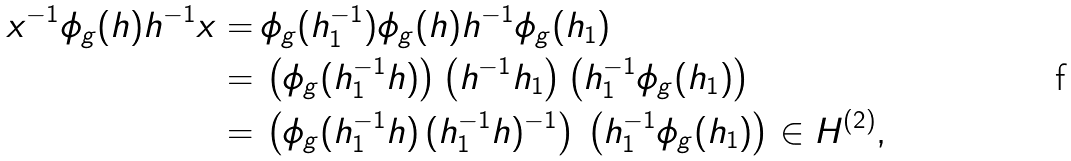<formula> <loc_0><loc_0><loc_500><loc_500>x ^ { - 1 } \phi _ { g } ( h ) h ^ { - 1 } x = & \, \phi _ { g } ( h _ { 1 } ^ { - 1 } ) \phi _ { g } ( h ) h ^ { - 1 } \phi _ { g } ( h _ { 1 } ) \\ = & \, \left ( \phi _ { g } ( h _ { 1 } ^ { - 1 } h ) \right ) \left ( h ^ { - 1 } h _ { 1 } \right ) \left ( h ^ { - 1 } _ { 1 } \phi _ { g } ( h _ { 1 } ) \right ) \\ = & \, \left ( \phi _ { g } ( h _ { 1 } ^ { - 1 } h ) \, ( h ^ { - 1 } _ { 1 } h ) ^ { - 1 } \right ) \, \left ( h ^ { - 1 } _ { 1 } \phi _ { g } ( h _ { 1 } ) \right ) \in H ^ { ( 2 ) } , \\</formula> 